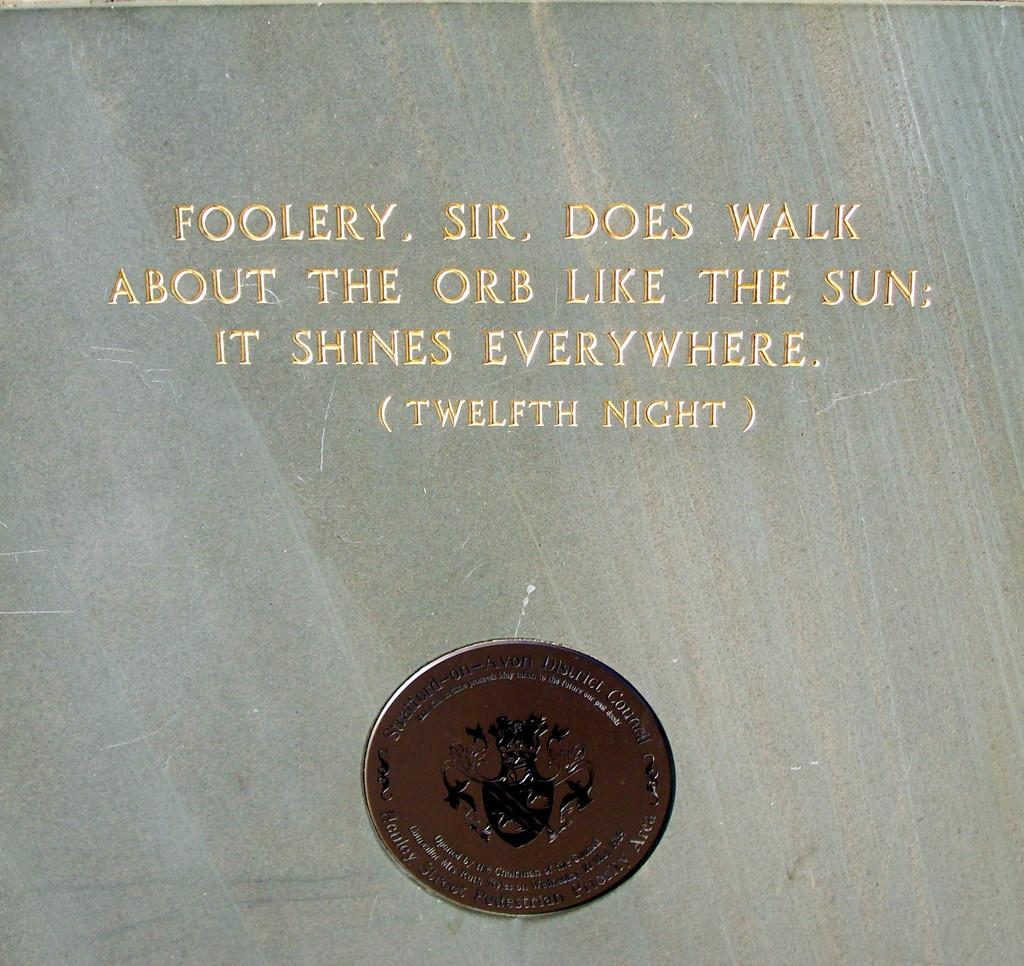<image>
Provide a brief description of the given image. A front of a document that says Foolery. Sir. Does Walk About The Orb. Like The Sun It Shines Everywhere (Twelfth Night). 